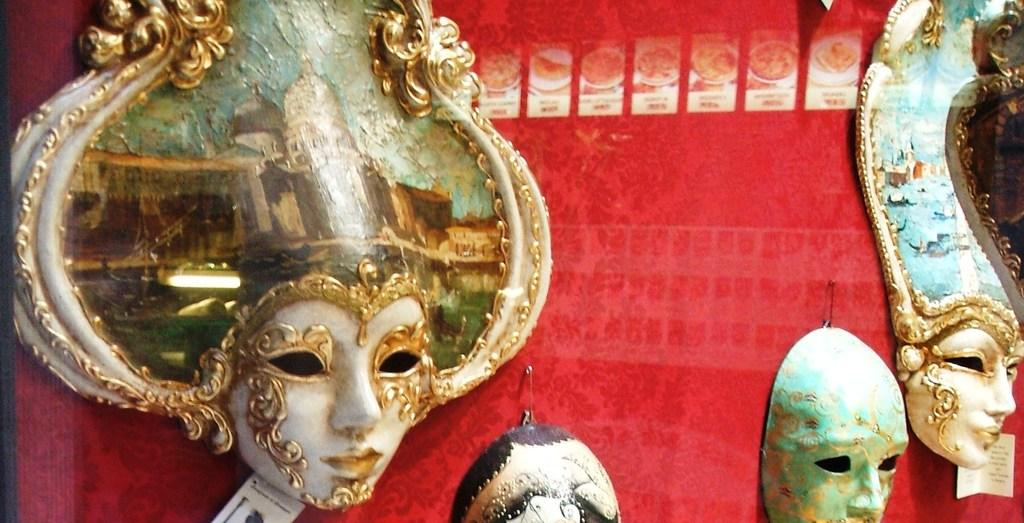What type of items can be seen in the image? There are masks and safety pins in the image. Can you describe the red object in the image? The red object is present in the image, but its specific nature is not mentioned in the provided facts. What might be the purpose of the safety pins in the image? The purpose of the safety pins in the image is not mentioned in the provided facts. What type of hate can be seen in the image? There is no hate present in the image; it features masks and safety pins. What angle is the pan being held at in the image? There is no pan present in the image. 